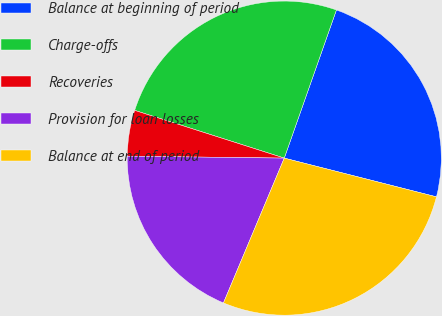<chart> <loc_0><loc_0><loc_500><loc_500><pie_chart><fcel>Balance at beginning of period<fcel>Charge-offs<fcel>Recoveries<fcel>Provision for loan losses<fcel>Balance at end of period<nl><fcel>23.58%<fcel>25.47%<fcel>4.72%<fcel>18.87%<fcel>27.36%<nl></chart> 